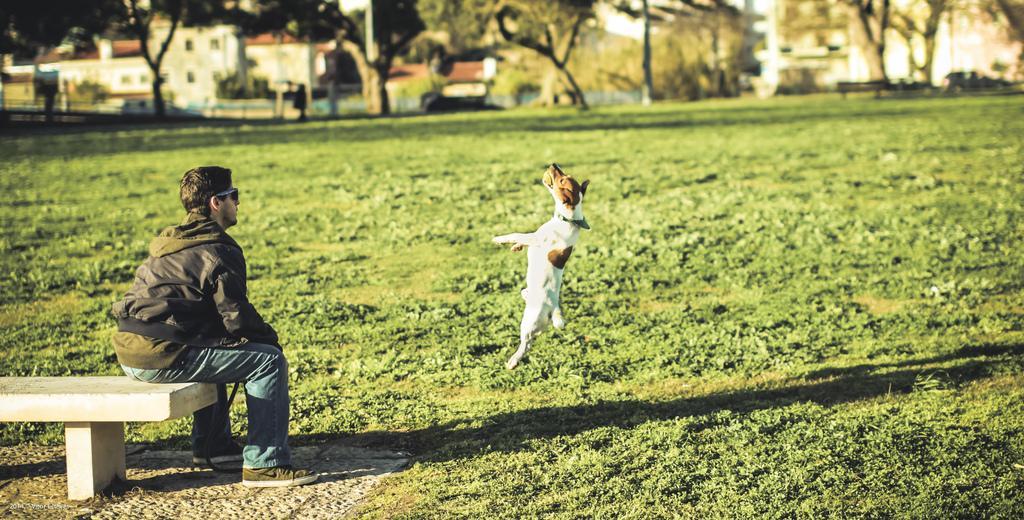How would you summarize this image in a sentence or two? This person is sitting on a bench. This dog is jumping, as we can see this dog is in air. Far there are number of trees and buildings. 